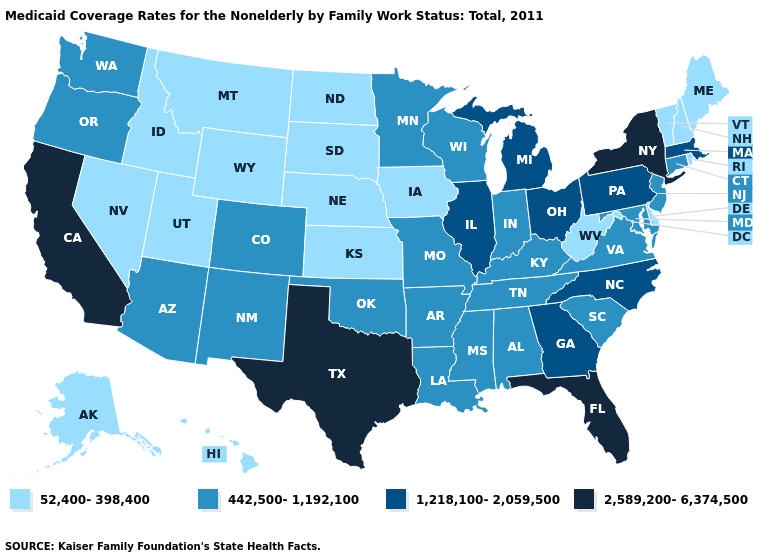Does the map have missing data?
Be succinct. No. What is the value of Maine?
Answer briefly. 52,400-398,400. Name the states that have a value in the range 1,218,100-2,059,500?
Short answer required. Georgia, Illinois, Massachusetts, Michigan, North Carolina, Ohio, Pennsylvania. Does Virginia have a higher value than Hawaii?
Write a very short answer. Yes. Which states have the highest value in the USA?
Keep it brief. California, Florida, New York, Texas. Which states hav the highest value in the South?
Quick response, please. Florida, Texas. What is the value of Massachusetts?
Give a very brief answer. 1,218,100-2,059,500. Name the states that have a value in the range 52,400-398,400?
Quick response, please. Alaska, Delaware, Hawaii, Idaho, Iowa, Kansas, Maine, Montana, Nebraska, Nevada, New Hampshire, North Dakota, Rhode Island, South Dakota, Utah, Vermont, West Virginia, Wyoming. Which states hav the highest value in the MidWest?
Answer briefly. Illinois, Michigan, Ohio. Name the states that have a value in the range 1,218,100-2,059,500?
Answer briefly. Georgia, Illinois, Massachusetts, Michigan, North Carolina, Ohio, Pennsylvania. What is the value of North Dakota?
Be succinct. 52,400-398,400. Does the first symbol in the legend represent the smallest category?
Be succinct. Yes. What is the highest value in the USA?
Answer briefly. 2,589,200-6,374,500. What is the value of Idaho?
Give a very brief answer. 52,400-398,400. 